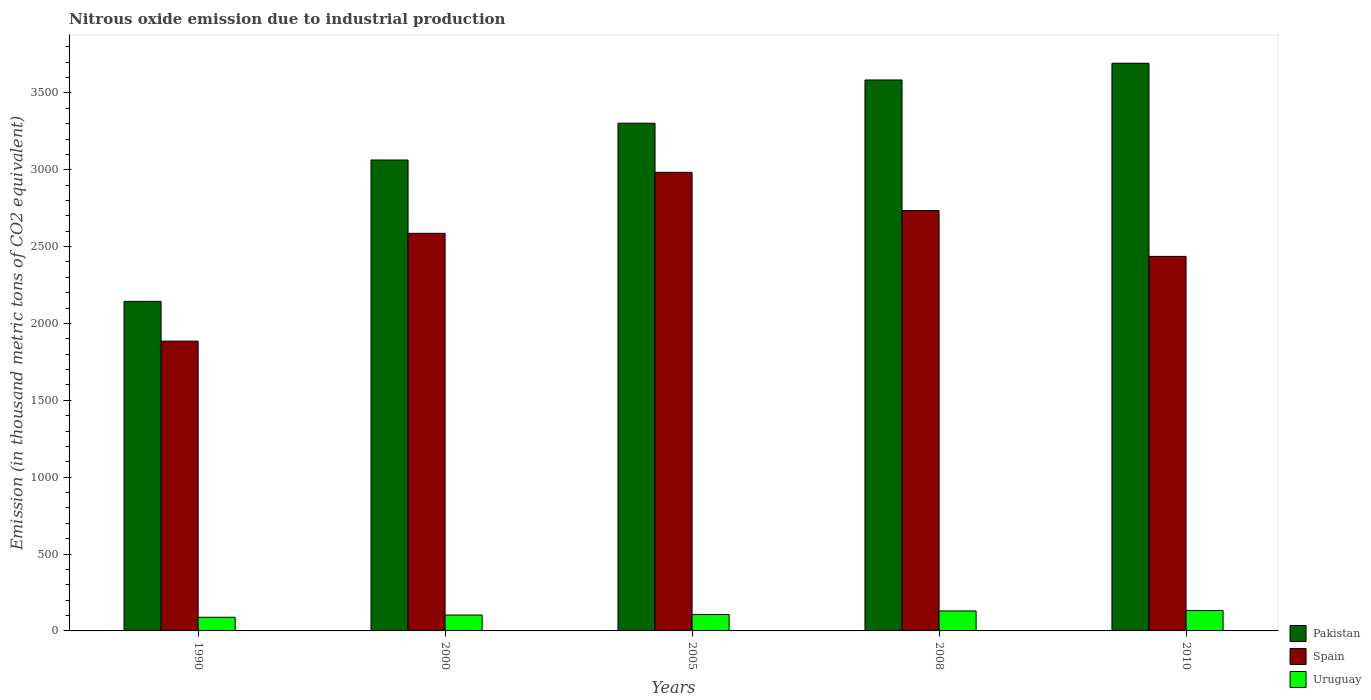How many different coloured bars are there?
Your answer should be very brief. 3. How many bars are there on the 2nd tick from the left?
Offer a very short reply. 3. How many bars are there on the 2nd tick from the right?
Your response must be concise. 3. What is the label of the 2nd group of bars from the left?
Keep it short and to the point. 2000. What is the amount of nitrous oxide emitted in Pakistan in 2008?
Ensure brevity in your answer.  3584. Across all years, what is the maximum amount of nitrous oxide emitted in Pakistan?
Your response must be concise. 3692.8. Across all years, what is the minimum amount of nitrous oxide emitted in Uruguay?
Make the answer very short. 88.8. In which year was the amount of nitrous oxide emitted in Spain maximum?
Make the answer very short. 2005. What is the total amount of nitrous oxide emitted in Spain in the graph?
Give a very brief answer. 1.26e+04. What is the difference between the amount of nitrous oxide emitted in Uruguay in 1990 and that in 2010?
Provide a succinct answer. -43.7. What is the difference between the amount of nitrous oxide emitted in Uruguay in 2008 and the amount of nitrous oxide emitted in Pakistan in 2010?
Offer a terse response. -3562.9. What is the average amount of nitrous oxide emitted in Pakistan per year?
Offer a terse response. 3157.4. In the year 2010, what is the difference between the amount of nitrous oxide emitted in Spain and amount of nitrous oxide emitted in Uruguay?
Provide a short and direct response. 2303.9. What is the ratio of the amount of nitrous oxide emitted in Uruguay in 1990 to that in 2008?
Make the answer very short. 0.68. Is the amount of nitrous oxide emitted in Spain in 1990 less than that in 2010?
Your response must be concise. Yes. What is the difference between the highest and the second highest amount of nitrous oxide emitted in Uruguay?
Provide a succinct answer. 2.6. What is the difference between the highest and the lowest amount of nitrous oxide emitted in Pakistan?
Your response must be concise. 1549. What does the 2nd bar from the left in 2008 represents?
Your answer should be compact. Spain. Is it the case that in every year, the sum of the amount of nitrous oxide emitted in Spain and amount of nitrous oxide emitted in Pakistan is greater than the amount of nitrous oxide emitted in Uruguay?
Your response must be concise. Yes. How many bars are there?
Give a very brief answer. 15. Are all the bars in the graph horizontal?
Ensure brevity in your answer.  No. How many years are there in the graph?
Make the answer very short. 5. What is the difference between two consecutive major ticks on the Y-axis?
Your answer should be compact. 500. Does the graph contain any zero values?
Offer a terse response. No. Where does the legend appear in the graph?
Offer a terse response. Bottom right. What is the title of the graph?
Offer a terse response. Nitrous oxide emission due to industrial production. Does "Bosnia and Herzegovina" appear as one of the legend labels in the graph?
Your answer should be compact. No. What is the label or title of the Y-axis?
Ensure brevity in your answer.  Emission (in thousand metric tons of CO2 equivalent). What is the Emission (in thousand metric tons of CO2 equivalent) of Pakistan in 1990?
Offer a terse response. 2143.8. What is the Emission (in thousand metric tons of CO2 equivalent) of Spain in 1990?
Ensure brevity in your answer.  1885.3. What is the Emission (in thousand metric tons of CO2 equivalent) in Uruguay in 1990?
Offer a very short reply. 88.8. What is the Emission (in thousand metric tons of CO2 equivalent) in Pakistan in 2000?
Offer a terse response. 3063.5. What is the Emission (in thousand metric tons of CO2 equivalent) in Spain in 2000?
Make the answer very short. 2586.5. What is the Emission (in thousand metric tons of CO2 equivalent) in Uruguay in 2000?
Provide a short and direct response. 103.4. What is the Emission (in thousand metric tons of CO2 equivalent) of Pakistan in 2005?
Ensure brevity in your answer.  3302.9. What is the Emission (in thousand metric tons of CO2 equivalent) in Spain in 2005?
Make the answer very short. 2983.4. What is the Emission (in thousand metric tons of CO2 equivalent) of Uruguay in 2005?
Make the answer very short. 106.6. What is the Emission (in thousand metric tons of CO2 equivalent) of Pakistan in 2008?
Your answer should be very brief. 3584. What is the Emission (in thousand metric tons of CO2 equivalent) of Spain in 2008?
Offer a very short reply. 2734.4. What is the Emission (in thousand metric tons of CO2 equivalent) of Uruguay in 2008?
Ensure brevity in your answer.  129.9. What is the Emission (in thousand metric tons of CO2 equivalent) in Pakistan in 2010?
Your answer should be very brief. 3692.8. What is the Emission (in thousand metric tons of CO2 equivalent) of Spain in 2010?
Your answer should be compact. 2436.4. What is the Emission (in thousand metric tons of CO2 equivalent) in Uruguay in 2010?
Provide a succinct answer. 132.5. Across all years, what is the maximum Emission (in thousand metric tons of CO2 equivalent) of Pakistan?
Ensure brevity in your answer.  3692.8. Across all years, what is the maximum Emission (in thousand metric tons of CO2 equivalent) of Spain?
Give a very brief answer. 2983.4. Across all years, what is the maximum Emission (in thousand metric tons of CO2 equivalent) of Uruguay?
Your answer should be compact. 132.5. Across all years, what is the minimum Emission (in thousand metric tons of CO2 equivalent) of Pakistan?
Make the answer very short. 2143.8. Across all years, what is the minimum Emission (in thousand metric tons of CO2 equivalent) of Spain?
Keep it short and to the point. 1885.3. Across all years, what is the minimum Emission (in thousand metric tons of CO2 equivalent) in Uruguay?
Your response must be concise. 88.8. What is the total Emission (in thousand metric tons of CO2 equivalent) in Pakistan in the graph?
Provide a short and direct response. 1.58e+04. What is the total Emission (in thousand metric tons of CO2 equivalent) in Spain in the graph?
Offer a terse response. 1.26e+04. What is the total Emission (in thousand metric tons of CO2 equivalent) of Uruguay in the graph?
Your answer should be compact. 561.2. What is the difference between the Emission (in thousand metric tons of CO2 equivalent) of Pakistan in 1990 and that in 2000?
Offer a terse response. -919.7. What is the difference between the Emission (in thousand metric tons of CO2 equivalent) in Spain in 1990 and that in 2000?
Give a very brief answer. -701.2. What is the difference between the Emission (in thousand metric tons of CO2 equivalent) of Uruguay in 1990 and that in 2000?
Your answer should be compact. -14.6. What is the difference between the Emission (in thousand metric tons of CO2 equivalent) in Pakistan in 1990 and that in 2005?
Provide a short and direct response. -1159.1. What is the difference between the Emission (in thousand metric tons of CO2 equivalent) in Spain in 1990 and that in 2005?
Offer a terse response. -1098.1. What is the difference between the Emission (in thousand metric tons of CO2 equivalent) of Uruguay in 1990 and that in 2005?
Offer a very short reply. -17.8. What is the difference between the Emission (in thousand metric tons of CO2 equivalent) of Pakistan in 1990 and that in 2008?
Provide a succinct answer. -1440.2. What is the difference between the Emission (in thousand metric tons of CO2 equivalent) in Spain in 1990 and that in 2008?
Ensure brevity in your answer.  -849.1. What is the difference between the Emission (in thousand metric tons of CO2 equivalent) of Uruguay in 1990 and that in 2008?
Your answer should be compact. -41.1. What is the difference between the Emission (in thousand metric tons of CO2 equivalent) of Pakistan in 1990 and that in 2010?
Provide a short and direct response. -1549. What is the difference between the Emission (in thousand metric tons of CO2 equivalent) of Spain in 1990 and that in 2010?
Offer a very short reply. -551.1. What is the difference between the Emission (in thousand metric tons of CO2 equivalent) in Uruguay in 1990 and that in 2010?
Offer a very short reply. -43.7. What is the difference between the Emission (in thousand metric tons of CO2 equivalent) in Pakistan in 2000 and that in 2005?
Offer a terse response. -239.4. What is the difference between the Emission (in thousand metric tons of CO2 equivalent) in Spain in 2000 and that in 2005?
Your answer should be very brief. -396.9. What is the difference between the Emission (in thousand metric tons of CO2 equivalent) in Pakistan in 2000 and that in 2008?
Ensure brevity in your answer.  -520.5. What is the difference between the Emission (in thousand metric tons of CO2 equivalent) of Spain in 2000 and that in 2008?
Offer a terse response. -147.9. What is the difference between the Emission (in thousand metric tons of CO2 equivalent) in Uruguay in 2000 and that in 2008?
Offer a terse response. -26.5. What is the difference between the Emission (in thousand metric tons of CO2 equivalent) in Pakistan in 2000 and that in 2010?
Your answer should be very brief. -629.3. What is the difference between the Emission (in thousand metric tons of CO2 equivalent) of Spain in 2000 and that in 2010?
Make the answer very short. 150.1. What is the difference between the Emission (in thousand metric tons of CO2 equivalent) of Uruguay in 2000 and that in 2010?
Your response must be concise. -29.1. What is the difference between the Emission (in thousand metric tons of CO2 equivalent) of Pakistan in 2005 and that in 2008?
Offer a very short reply. -281.1. What is the difference between the Emission (in thousand metric tons of CO2 equivalent) in Spain in 2005 and that in 2008?
Your response must be concise. 249. What is the difference between the Emission (in thousand metric tons of CO2 equivalent) in Uruguay in 2005 and that in 2008?
Offer a very short reply. -23.3. What is the difference between the Emission (in thousand metric tons of CO2 equivalent) in Pakistan in 2005 and that in 2010?
Offer a terse response. -389.9. What is the difference between the Emission (in thousand metric tons of CO2 equivalent) in Spain in 2005 and that in 2010?
Provide a short and direct response. 547. What is the difference between the Emission (in thousand metric tons of CO2 equivalent) in Uruguay in 2005 and that in 2010?
Give a very brief answer. -25.9. What is the difference between the Emission (in thousand metric tons of CO2 equivalent) of Pakistan in 2008 and that in 2010?
Provide a succinct answer. -108.8. What is the difference between the Emission (in thousand metric tons of CO2 equivalent) of Spain in 2008 and that in 2010?
Make the answer very short. 298. What is the difference between the Emission (in thousand metric tons of CO2 equivalent) of Pakistan in 1990 and the Emission (in thousand metric tons of CO2 equivalent) of Spain in 2000?
Offer a terse response. -442.7. What is the difference between the Emission (in thousand metric tons of CO2 equivalent) in Pakistan in 1990 and the Emission (in thousand metric tons of CO2 equivalent) in Uruguay in 2000?
Offer a very short reply. 2040.4. What is the difference between the Emission (in thousand metric tons of CO2 equivalent) in Spain in 1990 and the Emission (in thousand metric tons of CO2 equivalent) in Uruguay in 2000?
Give a very brief answer. 1781.9. What is the difference between the Emission (in thousand metric tons of CO2 equivalent) in Pakistan in 1990 and the Emission (in thousand metric tons of CO2 equivalent) in Spain in 2005?
Your response must be concise. -839.6. What is the difference between the Emission (in thousand metric tons of CO2 equivalent) of Pakistan in 1990 and the Emission (in thousand metric tons of CO2 equivalent) of Uruguay in 2005?
Your answer should be very brief. 2037.2. What is the difference between the Emission (in thousand metric tons of CO2 equivalent) in Spain in 1990 and the Emission (in thousand metric tons of CO2 equivalent) in Uruguay in 2005?
Keep it short and to the point. 1778.7. What is the difference between the Emission (in thousand metric tons of CO2 equivalent) in Pakistan in 1990 and the Emission (in thousand metric tons of CO2 equivalent) in Spain in 2008?
Give a very brief answer. -590.6. What is the difference between the Emission (in thousand metric tons of CO2 equivalent) of Pakistan in 1990 and the Emission (in thousand metric tons of CO2 equivalent) of Uruguay in 2008?
Provide a succinct answer. 2013.9. What is the difference between the Emission (in thousand metric tons of CO2 equivalent) of Spain in 1990 and the Emission (in thousand metric tons of CO2 equivalent) of Uruguay in 2008?
Give a very brief answer. 1755.4. What is the difference between the Emission (in thousand metric tons of CO2 equivalent) in Pakistan in 1990 and the Emission (in thousand metric tons of CO2 equivalent) in Spain in 2010?
Your answer should be very brief. -292.6. What is the difference between the Emission (in thousand metric tons of CO2 equivalent) in Pakistan in 1990 and the Emission (in thousand metric tons of CO2 equivalent) in Uruguay in 2010?
Give a very brief answer. 2011.3. What is the difference between the Emission (in thousand metric tons of CO2 equivalent) in Spain in 1990 and the Emission (in thousand metric tons of CO2 equivalent) in Uruguay in 2010?
Provide a short and direct response. 1752.8. What is the difference between the Emission (in thousand metric tons of CO2 equivalent) of Pakistan in 2000 and the Emission (in thousand metric tons of CO2 equivalent) of Spain in 2005?
Your response must be concise. 80.1. What is the difference between the Emission (in thousand metric tons of CO2 equivalent) in Pakistan in 2000 and the Emission (in thousand metric tons of CO2 equivalent) in Uruguay in 2005?
Keep it short and to the point. 2956.9. What is the difference between the Emission (in thousand metric tons of CO2 equivalent) of Spain in 2000 and the Emission (in thousand metric tons of CO2 equivalent) of Uruguay in 2005?
Offer a very short reply. 2479.9. What is the difference between the Emission (in thousand metric tons of CO2 equivalent) in Pakistan in 2000 and the Emission (in thousand metric tons of CO2 equivalent) in Spain in 2008?
Your answer should be very brief. 329.1. What is the difference between the Emission (in thousand metric tons of CO2 equivalent) in Pakistan in 2000 and the Emission (in thousand metric tons of CO2 equivalent) in Uruguay in 2008?
Provide a short and direct response. 2933.6. What is the difference between the Emission (in thousand metric tons of CO2 equivalent) of Spain in 2000 and the Emission (in thousand metric tons of CO2 equivalent) of Uruguay in 2008?
Your answer should be very brief. 2456.6. What is the difference between the Emission (in thousand metric tons of CO2 equivalent) of Pakistan in 2000 and the Emission (in thousand metric tons of CO2 equivalent) of Spain in 2010?
Offer a terse response. 627.1. What is the difference between the Emission (in thousand metric tons of CO2 equivalent) of Pakistan in 2000 and the Emission (in thousand metric tons of CO2 equivalent) of Uruguay in 2010?
Provide a short and direct response. 2931. What is the difference between the Emission (in thousand metric tons of CO2 equivalent) of Spain in 2000 and the Emission (in thousand metric tons of CO2 equivalent) of Uruguay in 2010?
Provide a short and direct response. 2454. What is the difference between the Emission (in thousand metric tons of CO2 equivalent) in Pakistan in 2005 and the Emission (in thousand metric tons of CO2 equivalent) in Spain in 2008?
Make the answer very short. 568.5. What is the difference between the Emission (in thousand metric tons of CO2 equivalent) in Pakistan in 2005 and the Emission (in thousand metric tons of CO2 equivalent) in Uruguay in 2008?
Your answer should be very brief. 3173. What is the difference between the Emission (in thousand metric tons of CO2 equivalent) in Spain in 2005 and the Emission (in thousand metric tons of CO2 equivalent) in Uruguay in 2008?
Your answer should be compact. 2853.5. What is the difference between the Emission (in thousand metric tons of CO2 equivalent) of Pakistan in 2005 and the Emission (in thousand metric tons of CO2 equivalent) of Spain in 2010?
Provide a succinct answer. 866.5. What is the difference between the Emission (in thousand metric tons of CO2 equivalent) of Pakistan in 2005 and the Emission (in thousand metric tons of CO2 equivalent) of Uruguay in 2010?
Give a very brief answer. 3170.4. What is the difference between the Emission (in thousand metric tons of CO2 equivalent) of Spain in 2005 and the Emission (in thousand metric tons of CO2 equivalent) of Uruguay in 2010?
Keep it short and to the point. 2850.9. What is the difference between the Emission (in thousand metric tons of CO2 equivalent) of Pakistan in 2008 and the Emission (in thousand metric tons of CO2 equivalent) of Spain in 2010?
Keep it short and to the point. 1147.6. What is the difference between the Emission (in thousand metric tons of CO2 equivalent) of Pakistan in 2008 and the Emission (in thousand metric tons of CO2 equivalent) of Uruguay in 2010?
Give a very brief answer. 3451.5. What is the difference between the Emission (in thousand metric tons of CO2 equivalent) in Spain in 2008 and the Emission (in thousand metric tons of CO2 equivalent) in Uruguay in 2010?
Make the answer very short. 2601.9. What is the average Emission (in thousand metric tons of CO2 equivalent) of Pakistan per year?
Make the answer very short. 3157.4. What is the average Emission (in thousand metric tons of CO2 equivalent) of Spain per year?
Give a very brief answer. 2525.2. What is the average Emission (in thousand metric tons of CO2 equivalent) in Uruguay per year?
Offer a very short reply. 112.24. In the year 1990, what is the difference between the Emission (in thousand metric tons of CO2 equivalent) in Pakistan and Emission (in thousand metric tons of CO2 equivalent) in Spain?
Provide a short and direct response. 258.5. In the year 1990, what is the difference between the Emission (in thousand metric tons of CO2 equivalent) of Pakistan and Emission (in thousand metric tons of CO2 equivalent) of Uruguay?
Keep it short and to the point. 2055. In the year 1990, what is the difference between the Emission (in thousand metric tons of CO2 equivalent) of Spain and Emission (in thousand metric tons of CO2 equivalent) of Uruguay?
Provide a succinct answer. 1796.5. In the year 2000, what is the difference between the Emission (in thousand metric tons of CO2 equivalent) of Pakistan and Emission (in thousand metric tons of CO2 equivalent) of Spain?
Your answer should be compact. 477. In the year 2000, what is the difference between the Emission (in thousand metric tons of CO2 equivalent) of Pakistan and Emission (in thousand metric tons of CO2 equivalent) of Uruguay?
Make the answer very short. 2960.1. In the year 2000, what is the difference between the Emission (in thousand metric tons of CO2 equivalent) in Spain and Emission (in thousand metric tons of CO2 equivalent) in Uruguay?
Make the answer very short. 2483.1. In the year 2005, what is the difference between the Emission (in thousand metric tons of CO2 equivalent) in Pakistan and Emission (in thousand metric tons of CO2 equivalent) in Spain?
Offer a terse response. 319.5. In the year 2005, what is the difference between the Emission (in thousand metric tons of CO2 equivalent) of Pakistan and Emission (in thousand metric tons of CO2 equivalent) of Uruguay?
Your answer should be compact. 3196.3. In the year 2005, what is the difference between the Emission (in thousand metric tons of CO2 equivalent) in Spain and Emission (in thousand metric tons of CO2 equivalent) in Uruguay?
Provide a succinct answer. 2876.8. In the year 2008, what is the difference between the Emission (in thousand metric tons of CO2 equivalent) of Pakistan and Emission (in thousand metric tons of CO2 equivalent) of Spain?
Your answer should be very brief. 849.6. In the year 2008, what is the difference between the Emission (in thousand metric tons of CO2 equivalent) of Pakistan and Emission (in thousand metric tons of CO2 equivalent) of Uruguay?
Your answer should be compact. 3454.1. In the year 2008, what is the difference between the Emission (in thousand metric tons of CO2 equivalent) in Spain and Emission (in thousand metric tons of CO2 equivalent) in Uruguay?
Your response must be concise. 2604.5. In the year 2010, what is the difference between the Emission (in thousand metric tons of CO2 equivalent) in Pakistan and Emission (in thousand metric tons of CO2 equivalent) in Spain?
Keep it short and to the point. 1256.4. In the year 2010, what is the difference between the Emission (in thousand metric tons of CO2 equivalent) in Pakistan and Emission (in thousand metric tons of CO2 equivalent) in Uruguay?
Give a very brief answer. 3560.3. In the year 2010, what is the difference between the Emission (in thousand metric tons of CO2 equivalent) of Spain and Emission (in thousand metric tons of CO2 equivalent) of Uruguay?
Your answer should be compact. 2303.9. What is the ratio of the Emission (in thousand metric tons of CO2 equivalent) of Pakistan in 1990 to that in 2000?
Make the answer very short. 0.7. What is the ratio of the Emission (in thousand metric tons of CO2 equivalent) in Spain in 1990 to that in 2000?
Keep it short and to the point. 0.73. What is the ratio of the Emission (in thousand metric tons of CO2 equivalent) of Uruguay in 1990 to that in 2000?
Your answer should be compact. 0.86. What is the ratio of the Emission (in thousand metric tons of CO2 equivalent) of Pakistan in 1990 to that in 2005?
Give a very brief answer. 0.65. What is the ratio of the Emission (in thousand metric tons of CO2 equivalent) in Spain in 1990 to that in 2005?
Provide a short and direct response. 0.63. What is the ratio of the Emission (in thousand metric tons of CO2 equivalent) in Uruguay in 1990 to that in 2005?
Provide a succinct answer. 0.83. What is the ratio of the Emission (in thousand metric tons of CO2 equivalent) of Pakistan in 1990 to that in 2008?
Offer a terse response. 0.6. What is the ratio of the Emission (in thousand metric tons of CO2 equivalent) in Spain in 1990 to that in 2008?
Keep it short and to the point. 0.69. What is the ratio of the Emission (in thousand metric tons of CO2 equivalent) of Uruguay in 1990 to that in 2008?
Ensure brevity in your answer.  0.68. What is the ratio of the Emission (in thousand metric tons of CO2 equivalent) of Pakistan in 1990 to that in 2010?
Keep it short and to the point. 0.58. What is the ratio of the Emission (in thousand metric tons of CO2 equivalent) of Spain in 1990 to that in 2010?
Make the answer very short. 0.77. What is the ratio of the Emission (in thousand metric tons of CO2 equivalent) of Uruguay in 1990 to that in 2010?
Give a very brief answer. 0.67. What is the ratio of the Emission (in thousand metric tons of CO2 equivalent) in Pakistan in 2000 to that in 2005?
Make the answer very short. 0.93. What is the ratio of the Emission (in thousand metric tons of CO2 equivalent) of Spain in 2000 to that in 2005?
Make the answer very short. 0.87. What is the ratio of the Emission (in thousand metric tons of CO2 equivalent) in Uruguay in 2000 to that in 2005?
Provide a succinct answer. 0.97. What is the ratio of the Emission (in thousand metric tons of CO2 equivalent) of Pakistan in 2000 to that in 2008?
Provide a succinct answer. 0.85. What is the ratio of the Emission (in thousand metric tons of CO2 equivalent) in Spain in 2000 to that in 2008?
Provide a succinct answer. 0.95. What is the ratio of the Emission (in thousand metric tons of CO2 equivalent) in Uruguay in 2000 to that in 2008?
Keep it short and to the point. 0.8. What is the ratio of the Emission (in thousand metric tons of CO2 equivalent) of Pakistan in 2000 to that in 2010?
Offer a very short reply. 0.83. What is the ratio of the Emission (in thousand metric tons of CO2 equivalent) of Spain in 2000 to that in 2010?
Give a very brief answer. 1.06. What is the ratio of the Emission (in thousand metric tons of CO2 equivalent) of Uruguay in 2000 to that in 2010?
Your response must be concise. 0.78. What is the ratio of the Emission (in thousand metric tons of CO2 equivalent) in Pakistan in 2005 to that in 2008?
Provide a succinct answer. 0.92. What is the ratio of the Emission (in thousand metric tons of CO2 equivalent) of Spain in 2005 to that in 2008?
Give a very brief answer. 1.09. What is the ratio of the Emission (in thousand metric tons of CO2 equivalent) in Uruguay in 2005 to that in 2008?
Your answer should be compact. 0.82. What is the ratio of the Emission (in thousand metric tons of CO2 equivalent) of Pakistan in 2005 to that in 2010?
Your response must be concise. 0.89. What is the ratio of the Emission (in thousand metric tons of CO2 equivalent) of Spain in 2005 to that in 2010?
Your response must be concise. 1.22. What is the ratio of the Emission (in thousand metric tons of CO2 equivalent) in Uruguay in 2005 to that in 2010?
Offer a terse response. 0.8. What is the ratio of the Emission (in thousand metric tons of CO2 equivalent) in Pakistan in 2008 to that in 2010?
Offer a very short reply. 0.97. What is the ratio of the Emission (in thousand metric tons of CO2 equivalent) in Spain in 2008 to that in 2010?
Keep it short and to the point. 1.12. What is the ratio of the Emission (in thousand metric tons of CO2 equivalent) in Uruguay in 2008 to that in 2010?
Provide a short and direct response. 0.98. What is the difference between the highest and the second highest Emission (in thousand metric tons of CO2 equivalent) in Pakistan?
Offer a terse response. 108.8. What is the difference between the highest and the second highest Emission (in thousand metric tons of CO2 equivalent) in Spain?
Your answer should be very brief. 249. What is the difference between the highest and the lowest Emission (in thousand metric tons of CO2 equivalent) in Pakistan?
Ensure brevity in your answer.  1549. What is the difference between the highest and the lowest Emission (in thousand metric tons of CO2 equivalent) of Spain?
Your answer should be compact. 1098.1. What is the difference between the highest and the lowest Emission (in thousand metric tons of CO2 equivalent) of Uruguay?
Provide a succinct answer. 43.7. 